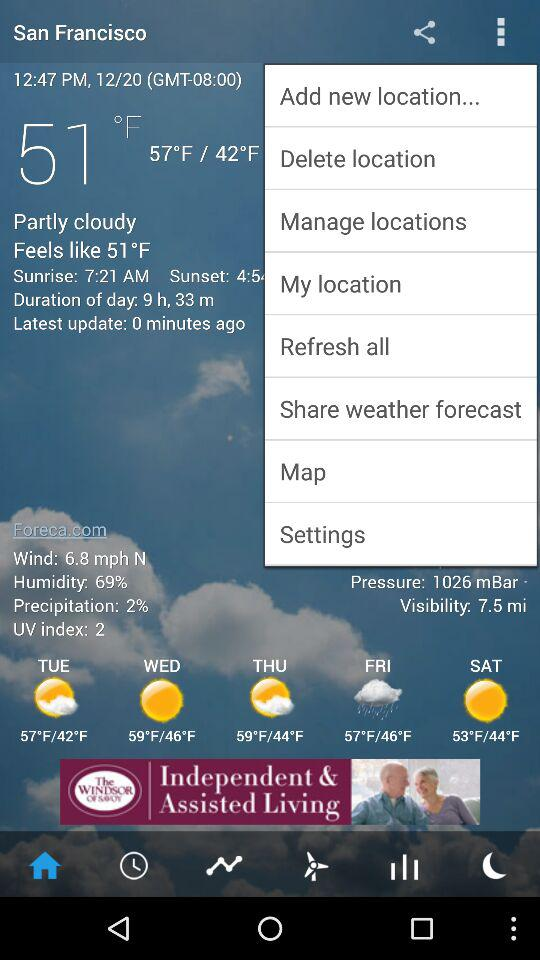What is the wind speed? The wind speed is 6.8 mph. 